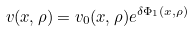Convert formula to latex. <formula><loc_0><loc_0><loc_500><loc_500>v ( x , \rho ) = v _ { 0 } ( x , \rho ) e ^ { \delta \Phi _ { 1 } ( x , \rho ) }</formula> 